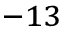Convert formula to latex. <formula><loc_0><loc_0><loc_500><loc_500>^ { - 1 3 }</formula> 